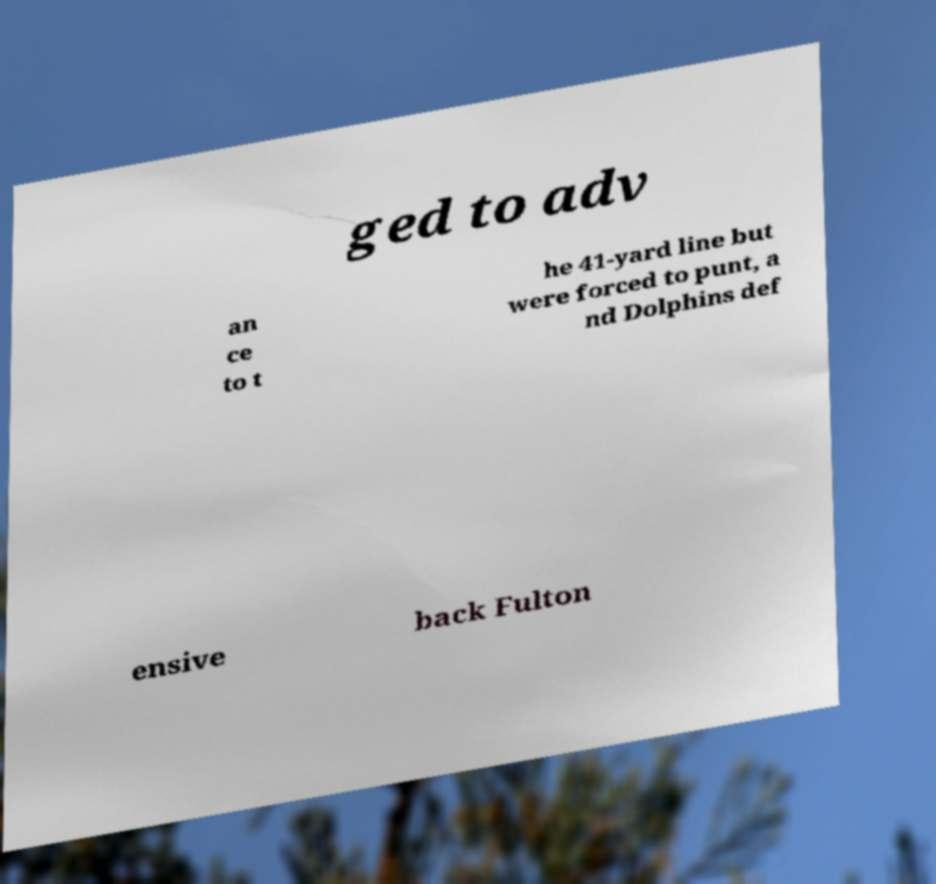Please identify and transcribe the text found in this image. ged to adv an ce to t he 41-yard line but were forced to punt, a nd Dolphins def ensive back Fulton 